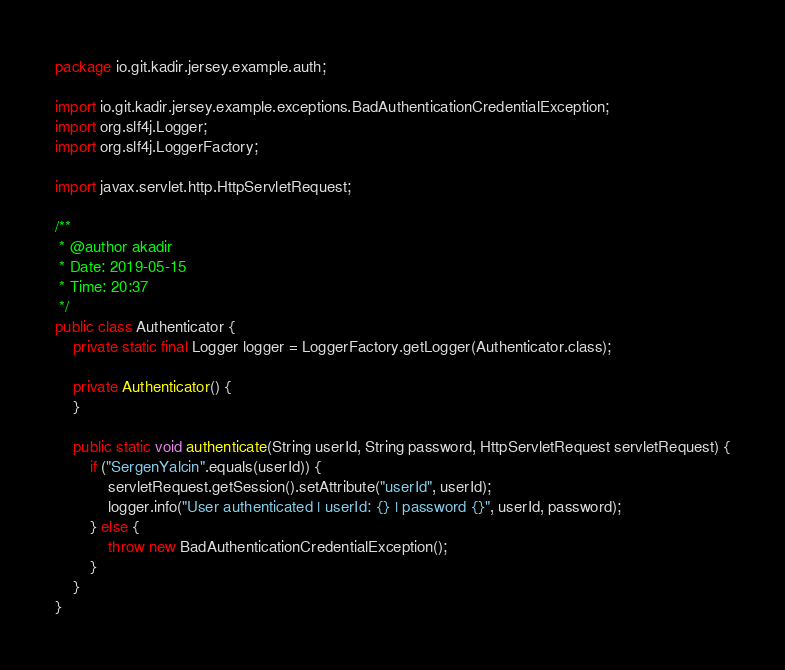Convert code to text. <code><loc_0><loc_0><loc_500><loc_500><_Java_>package io.git.kadir.jersey.example.auth;

import io.git.kadir.jersey.example.exceptions.BadAuthenticationCredentialException;
import org.slf4j.Logger;
import org.slf4j.LoggerFactory;

import javax.servlet.http.HttpServletRequest;

/**
 * @author akadir
 * Date: 2019-05-15
 * Time: 20:37
 */
public class Authenticator {
    private static final Logger logger = LoggerFactory.getLogger(Authenticator.class);

    private Authenticator() {
    }

    public static void authenticate(String userId, String password, HttpServletRequest servletRequest) {
        if ("SergenYalcin".equals(userId)) {
            servletRequest.getSession().setAttribute("userId", userId);
            logger.info("User authenticated | userId: {} | password {}", userId, password);
        } else {
            throw new BadAuthenticationCredentialException();
        }
    }
}
</code> 